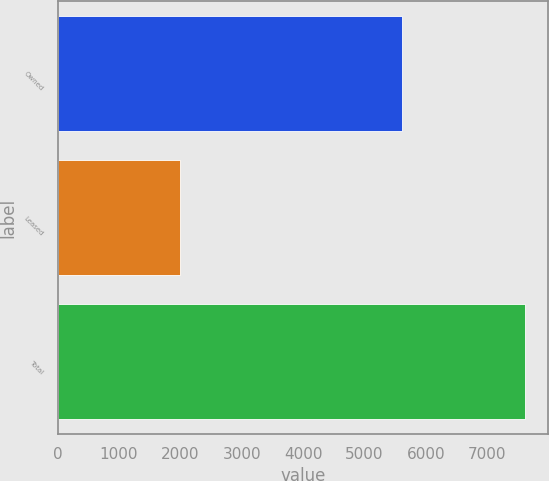Convert chart. <chart><loc_0><loc_0><loc_500><loc_500><bar_chart><fcel>Owned<fcel>Leased<fcel>Total<nl><fcel>5616<fcel>1998<fcel>7614<nl></chart> 